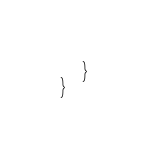<code> <loc_0><loc_0><loc_500><loc_500><_Swift_>    }
}

</code> 